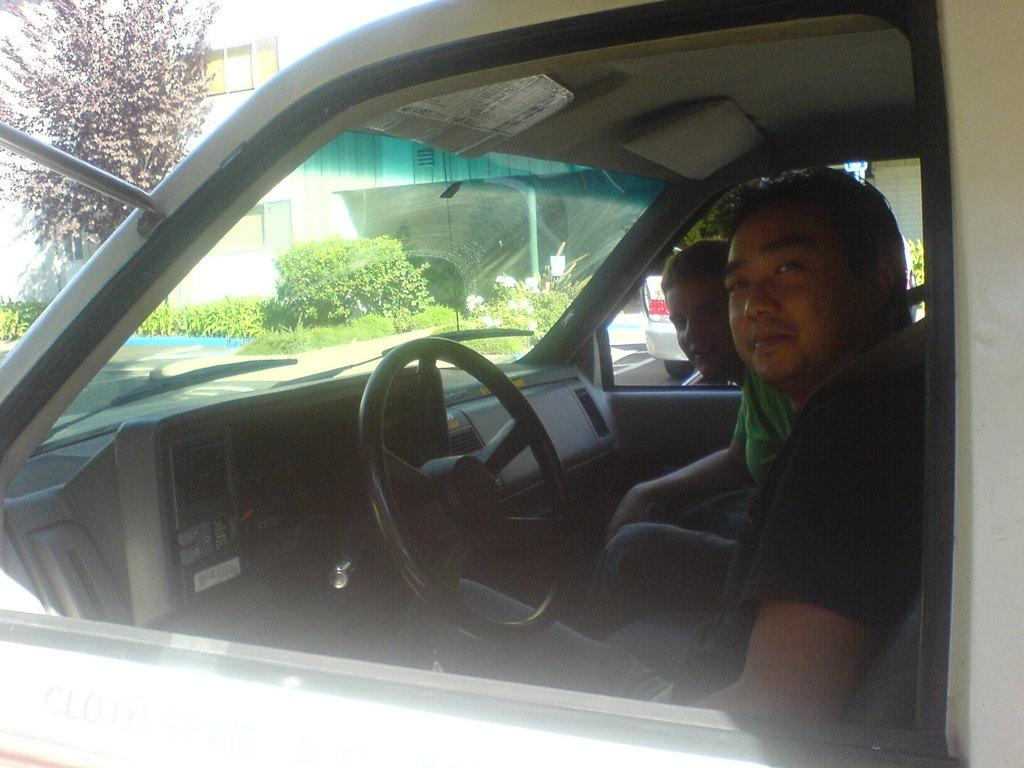What types of objects are present in the image? There are vehicles in the image. How many people can be seen in the image? There are two people in the image. What can be seen in the background of the image? There are trees and a building in the background of the image. What type of bean is being used as a pet in the image? There is no bean or pet present in the image. Can you tell me how many airplanes are visible in the image? There is no airplane present in the image. 